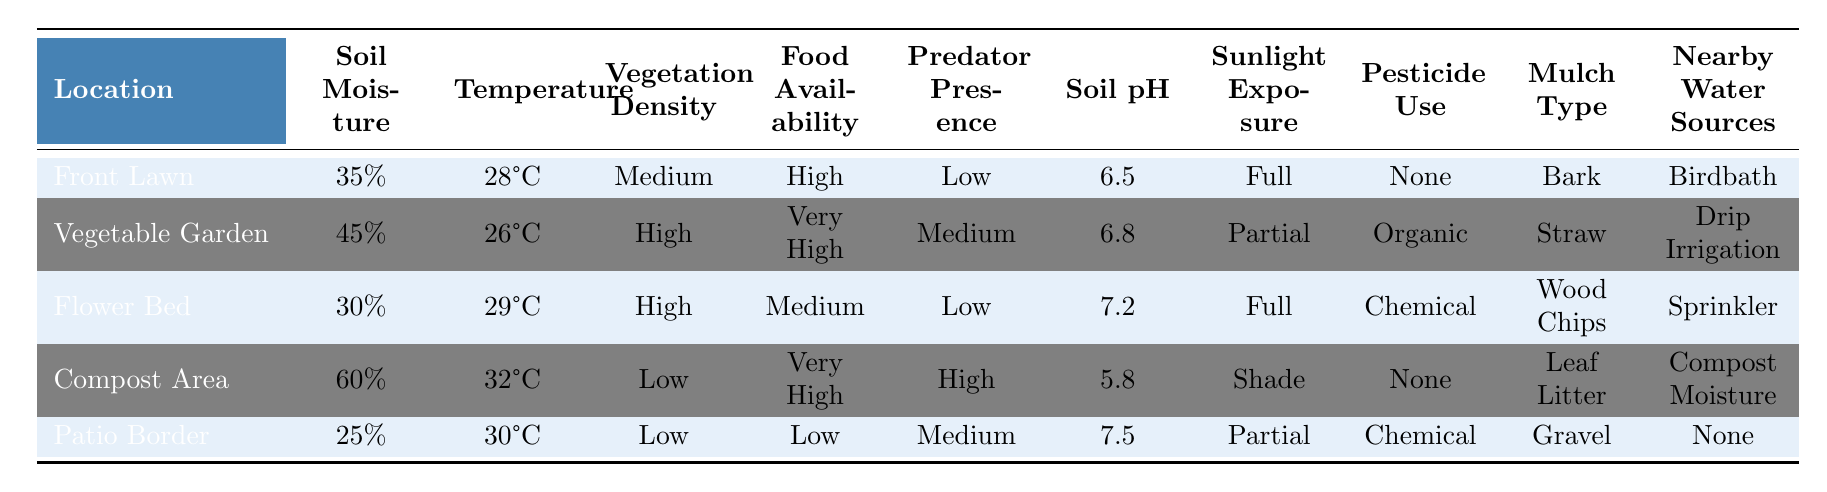What is the soil moisture level in the vegetable garden? The table shows the vegetable garden has a soil moisture level of 45%.
Answer: 45% Which location has the highest food availability? Comparing the food availability across all locations, the compost area has "very high" food availability, more than any other area.
Answer: Compost Area Is the predator presence low or high in the flower bed? The table indicates that the predator presence in the flower bed is marked as "low".
Answer: Low What is the average soil pH of the compost area and the patio border? The soil pH for the compost area is 5.8 and for the patio border is 7.5; the average is (5.8 + 7.5) / 2 = 6.65.
Answer: 6.65 In which location is the sunlight exposure classified as "shade"? The table notes that the compost area is the only location where the sunlight exposure is classified as "shade".
Answer: Compost Area Does the flower bed use chemical pesticides? According to the table, the flower bed does use chemical pesticides.
Answer: Yes What is the difference in soil moisture between the front lawn and the patio border? The front lawn has a soil moisture of 35% and the patio border has 25%; thus, the difference is 35% - 25% = 10%.
Answer: 10% How many locations have high vegetation density? Both the vegetable garden and the flower bed have a vegetation density classified as "high", resulting in a total of 2 locations.
Answer: 2 Is there any nearby water source in the patio border? The data shows that the patio border has "none" listed for nearby water sources, indicating there is no source.
Answer: No What is the temperature in the flower bed? The temperature listed for the flower bed is 29°C.
Answer: 29°C Which location has the lowest soil moisture? The patio border has the lowest soil moisture level of 25%, lower than all other locations.
Answer: Patio Border 